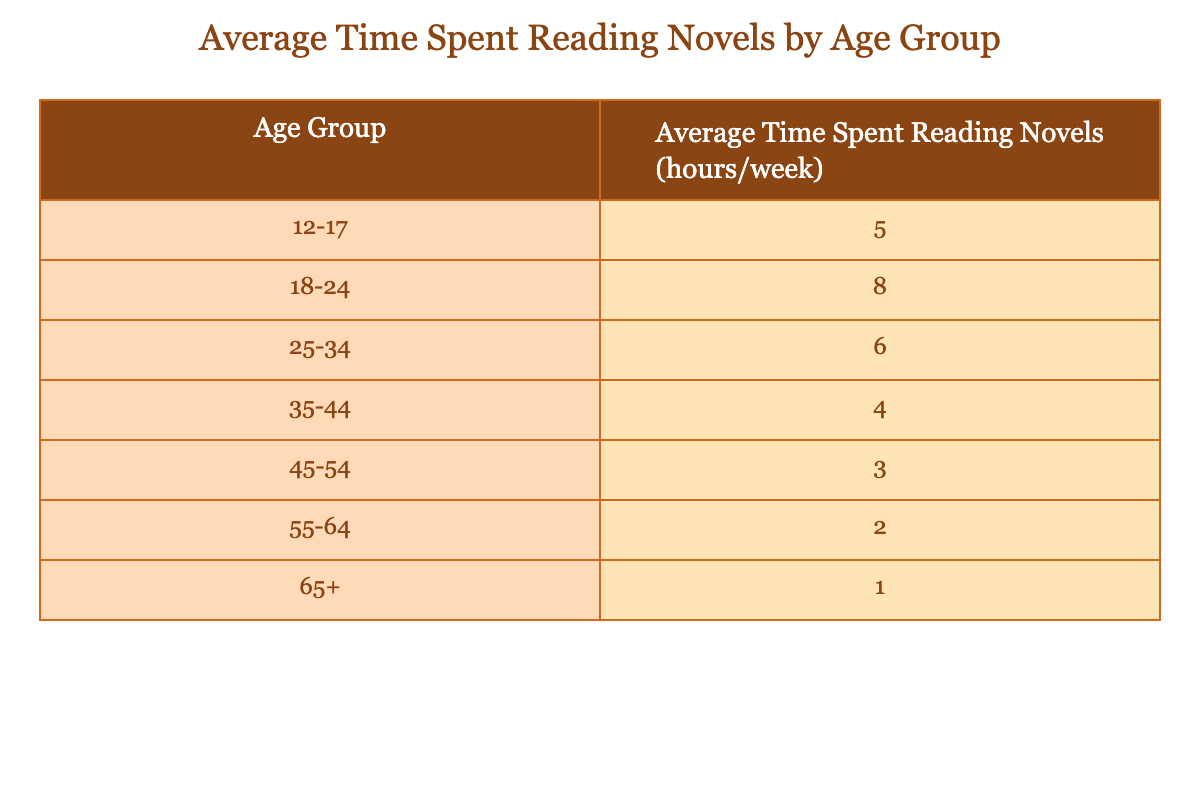What is the average time spent reading novels by the age group 25-34? The table shows that the average time spent reading novels for the age group 25-34 is 6 hours per week.
Answer: 6 hours Which age group spends the least time reading novels? By examining the table, it's clear that the age group 65+ spends the least time reading novels, with an average of 1 hour per week.
Answer: 65+ What is the difference in average reading time between the age groups 18-24 and 45-54? The average time for the age group 18-24 is 8 hours and for the age group 45-54 is 3 hours. The difference is calculated as 8 - 3 = 5 hours.
Answer: 5 hours Is the average reading time for the age group 35-44 greater than that for the age group 55-64? From the table, the average reading time for the age group 35-44 is 4 hours, while for 55-64 it is 2 hours. Since 4 is greater than 2, the statement is true.
Answer: Yes What is the total average reading time of the age groups 12-17, 18-24, and 25-34 combined? To find the total average, we add the average times for these age groups: 5 + 8 + 6 = 19 hours. The total average reading time for these three groups is 19 hours per week.
Answer: 19 hours Which age group has an average reading time that is below the overall average of the given data? The average reading times are 5, 8, 6, 4, 3, 2, and 1 hours respectively. The overall average is calculated as (5 + 8 + 6 + 4 + 3 + 2 + 1)/7 = 4.14 hours. The age groups 35-44, 45-54, 55-64, and 65+ all have averages that are below this overall average.
Answer: 35-44, 45-54, 55-64, 65+ What is the relationship between age and average reading time as seen in the table? The table indicates a trend where the average reading time decreases with increasing age. For instance, as age groups progress from 12-17 to 65+, the average time spent reading novels declines from 5 hours to 1 hour.
Answer: Decreases with age What is the range of average reading time across all age groups? The maximum average reading time is 8 hours (age group 18-24) and the minimum is 1 hour (age group 65+). The range is calculated as 8 - 1 = 7 hours, showing the spread of reading time across the groups.
Answer: 7 hours 